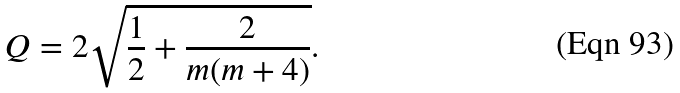<formula> <loc_0><loc_0><loc_500><loc_500>Q = 2 \sqrt { \frac { 1 } { 2 } + \frac { 2 } { m ( m + 4 ) } } .</formula> 